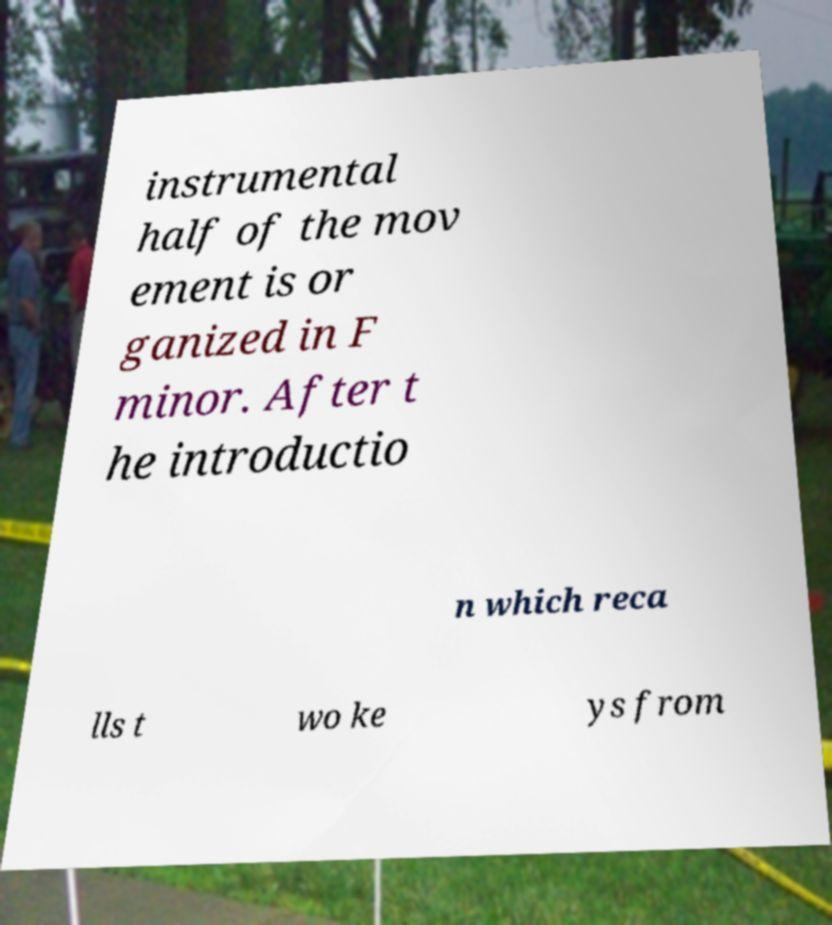Could you assist in decoding the text presented in this image and type it out clearly? instrumental half of the mov ement is or ganized in F minor. After t he introductio n which reca lls t wo ke ys from 